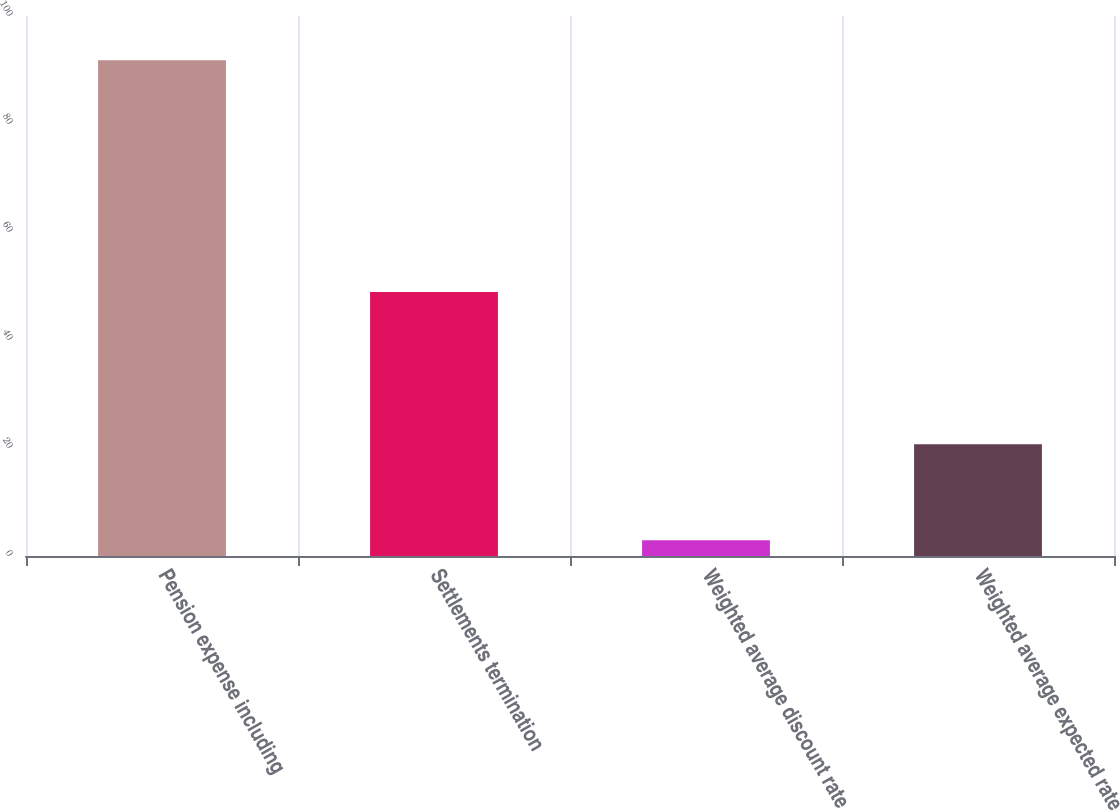Convert chart. <chart><loc_0><loc_0><loc_500><loc_500><bar_chart><fcel>Pension expense including<fcel>Settlements termination<fcel>Weighted average discount rate<fcel>Weighted average expected rate<nl><fcel>91.8<fcel>48.9<fcel>2.9<fcel>20.68<nl></chart> 